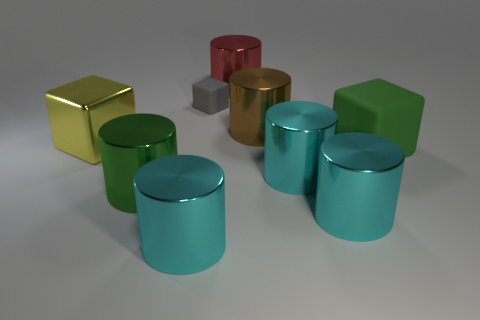Are there more large cubes that are to the right of the big red thing than large blue matte blocks?
Your response must be concise. Yes. What number of other red things are the same size as the red metal thing?
Ensure brevity in your answer.  0. What number of objects are either yellow things or shiny objects that are in front of the green metal cylinder?
Provide a succinct answer. 3. The large shiny thing that is behind the green cylinder and in front of the green cube is what color?
Your response must be concise. Cyan. Do the green matte cube and the green metallic cylinder have the same size?
Keep it short and to the point. Yes. There is a matte block that is behind the yellow metallic block; what color is it?
Make the answer very short. Gray. Is there a object that has the same color as the large matte cube?
Provide a short and direct response. Yes. What is the color of the matte cube that is the same size as the green cylinder?
Provide a succinct answer. Green. Is the shape of the red thing the same as the brown thing?
Your answer should be very brief. Yes. There is a tiny gray thing that is behind the large green cube; what is it made of?
Offer a terse response. Rubber. 